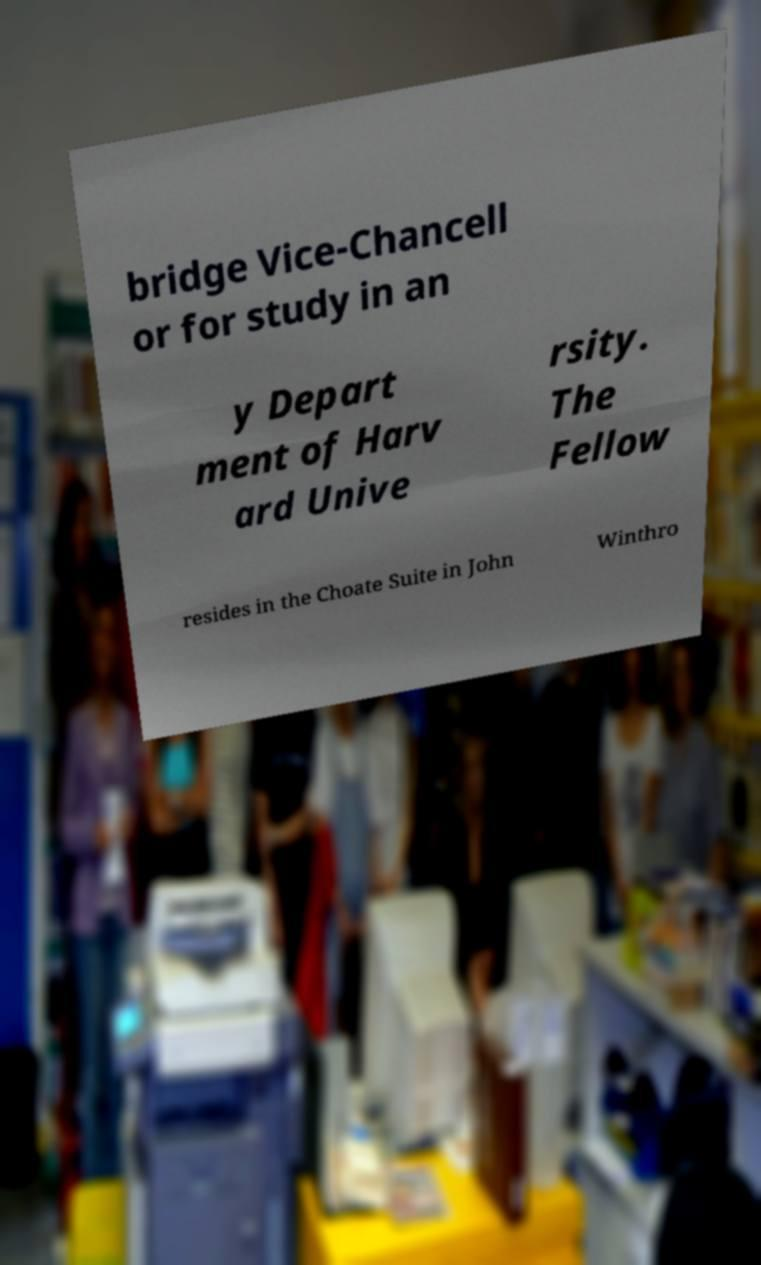For documentation purposes, I need the text within this image transcribed. Could you provide that? bridge Vice-Chancell or for study in an y Depart ment of Harv ard Unive rsity. The Fellow resides in the Choate Suite in John Winthro 